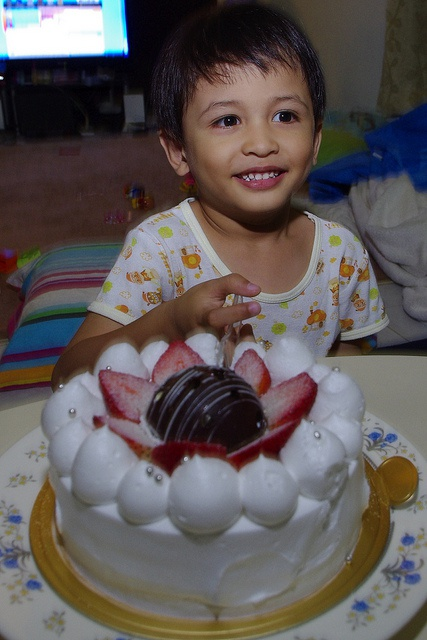Describe the objects in this image and their specific colors. I can see cake in lightblue, gray, darkgray, black, and maroon tones and people in lightblue, black, darkgray, and gray tones in this image. 